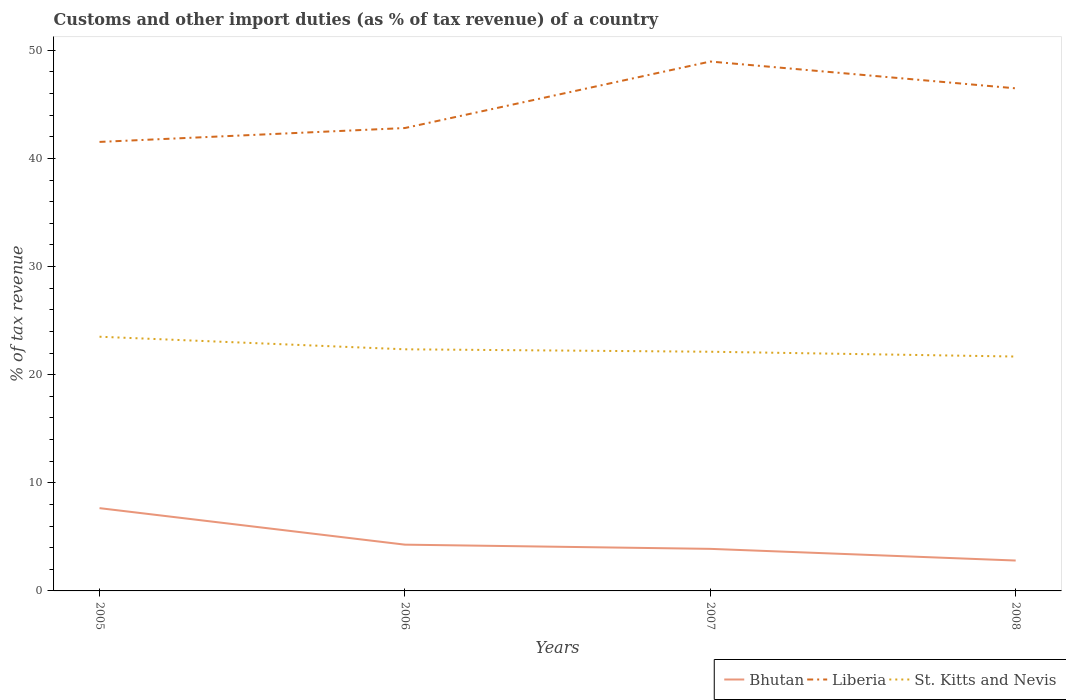Is the number of lines equal to the number of legend labels?
Keep it short and to the point. Yes. Across all years, what is the maximum percentage of tax revenue from customs in St. Kitts and Nevis?
Make the answer very short. 21.68. What is the total percentage of tax revenue from customs in Bhutan in the graph?
Give a very brief answer. 1.47. What is the difference between the highest and the second highest percentage of tax revenue from customs in St. Kitts and Nevis?
Ensure brevity in your answer.  1.83. What is the difference between the highest and the lowest percentage of tax revenue from customs in Liberia?
Your answer should be compact. 2. How many lines are there?
Your answer should be very brief. 3. How many years are there in the graph?
Ensure brevity in your answer.  4. What is the difference between two consecutive major ticks on the Y-axis?
Keep it short and to the point. 10. Are the values on the major ticks of Y-axis written in scientific E-notation?
Your answer should be very brief. No. How many legend labels are there?
Offer a terse response. 3. What is the title of the graph?
Offer a terse response. Customs and other import duties (as % of tax revenue) of a country. Does "Jamaica" appear as one of the legend labels in the graph?
Offer a very short reply. No. What is the label or title of the Y-axis?
Keep it short and to the point. % of tax revenue. What is the % of tax revenue in Bhutan in 2005?
Provide a succinct answer. 7.66. What is the % of tax revenue in Liberia in 2005?
Your answer should be compact. 41.53. What is the % of tax revenue of St. Kitts and Nevis in 2005?
Ensure brevity in your answer.  23.51. What is the % of tax revenue of Bhutan in 2006?
Offer a terse response. 4.28. What is the % of tax revenue in Liberia in 2006?
Give a very brief answer. 42.81. What is the % of tax revenue in St. Kitts and Nevis in 2006?
Provide a short and direct response. 22.35. What is the % of tax revenue in Bhutan in 2007?
Provide a succinct answer. 3.89. What is the % of tax revenue of Liberia in 2007?
Make the answer very short. 48.96. What is the % of tax revenue in St. Kitts and Nevis in 2007?
Your answer should be compact. 22.12. What is the % of tax revenue of Bhutan in 2008?
Give a very brief answer. 2.81. What is the % of tax revenue of Liberia in 2008?
Offer a terse response. 46.48. What is the % of tax revenue in St. Kitts and Nevis in 2008?
Provide a succinct answer. 21.68. Across all years, what is the maximum % of tax revenue in Bhutan?
Offer a terse response. 7.66. Across all years, what is the maximum % of tax revenue of Liberia?
Provide a short and direct response. 48.96. Across all years, what is the maximum % of tax revenue of St. Kitts and Nevis?
Offer a terse response. 23.51. Across all years, what is the minimum % of tax revenue in Bhutan?
Your response must be concise. 2.81. Across all years, what is the minimum % of tax revenue of Liberia?
Ensure brevity in your answer.  41.53. Across all years, what is the minimum % of tax revenue of St. Kitts and Nevis?
Your answer should be very brief. 21.68. What is the total % of tax revenue of Bhutan in the graph?
Ensure brevity in your answer.  18.64. What is the total % of tax revenue of Liberia in the graph?
Make the answer very short. 179.79. What is the total % of tax revenue in St. Kitts and Nevis in the graph?
Provide a succinct answer. 89.66. What is the difference between the % of tax revenue in Bhutan in 2005 and that in 2006?
Provide a short and direct response. 3.38. What is the difference between the % of tax revenue in Liberia in 2005 and that in 2006?
Your response must be concise. -1.28. What is the difference between the % of tax revenue of St. Kitts and Nevis in 2005 and that in 2006?
Make the answer very short. 1.16. What is the difference between the % of tax revenue in Bhutan in 2005 and that in 2007?
Ensure brevity in your answer.  3.77. What is the difference between the % of tax revenue in Liberia in 2005 and that in 2007?
Your answer should be compact. -7.44. What is the difference between the % of tax revenue in St. Kitts and Nevis in 2005 and that in 2007?
Keep it short and to the point. 1.39. What is the difference between the % of tax revenue in Bhutan in 2005 and that in 2008?
Your answer should be very brief. 4.85. What is the difference between the % of tax revenue of Liberia in 2005 and that in 2008?
Provide a short and direct response. -4.96. What is the difference between the % of tax revenue in St. Kitts and Nevis in 2005 and that in 2008?
Provide a succinct answer. 1.83. What is the difference between the % of tax revenue in Bhutan in 2006 and that in 2007?
Offer a terse response. 0.39. What is the difference between the % of tax revenue of Liberia in 2006 and that in 2007?
Make the answer very short. -6.15. What is the difference between the % of tax revenue of St. Kitts and Nevis in 2006 and that in 2007?
Your answer should be very brief. 0.22. What is the difference between the % of tax revenue in Bhutan in 2006 and that in 2008?
Offer a very short reply. 1.47. What is the difference between the % of tax revenue of Liberia in 2006 and that in 2008?
Ensure brevity in your answer.  -3.67. What is the difference between the % of tax revenue of St. Kitts and Nevis in 2006 and that in 2008?
Provide a succinct answer. 0.67. What is the difference between the % of tax revenue of Bhutan in 2007 and that in 2008?
Your response must be concise. 1.08. What is the difference between the % of tax revenue of Liberia in 2007 and that in 2008?
Keep it short and to the point. 2.48. What is the difference between the % of tax revenue of St. Kitts and Nevis in 2007 and that in 2008?
Your response must be concise. 0.44. What is the difference between the % of tax revenue of Bhutan in 2005 and the % of tax revenue of Liberia in 2006?
Provide a succinct answer. -35.16. What is the difference between the % of tax revenue in Bhutan in 2005 and the % of tax revenue in St. Kitts and Nevis in 2006?
Give a very brief answer. -14.69. What is the difference between the % of tax revenue of Liberia in 2005 and the % of tax revenue of St. Kitts and Nevis in 2006?
Offer a very short reply. 19.18. What is the difference between the % of tax revenue in Bhutan in 2005 and the % of tax revenue in Liberia in 2007?
Keep it short and to the point. -41.31. What is the difference between the % of tax revenue of Bhutan in 2005 and the % of tax revenue of St. Kitts and Nevis in 2007?
Offer a terse response. -14.47. What is the difference between the % of tax revenue of Liberia in 2005 and the % of tax revenue of St. Kitts and Nevis in 2007?
Offer a terse response. 19.41. What is the difference between the % of tax revenue in Bhutan in 2005 and the % of tax revenue in Liberia in 2008?
Make the answer very short. -38.83. What is the difference between the % of tax revenue in Bhutan in 2005 and the % of tax revenue in St. Kitts and Nevis in 2008?
Offer a very short reply. -14.02. What is the difference between the % of tax revenue in Liberia in 2005 and the % of tax revenue in St. Kitts and Nevis in 2008?
Keep it short and to the point. 19.85. What is the difference between the % of tax revenue in Bhutan in 2006 and the % of tax revenue in Liberia in 2007?
Offer a terse response. -44.68. What is the difference between the % of tax revenue in Bhutan in 2006 and the % of tax revenue in St. Kitts and Nevis in 2007?
Give a very brief answer. -17.84. What is the difference between the % of tax revenue of Liberia in 2006 and the % of tax revenue of St. Kitts and Nevis in 2007?
Make the answer very short. 20.69. What is the difference between the % of tax revenue of Bhutan in 2006 and the % of tax revenue of Liberia in 2008?
Your response must be concise. -42.21. What is the difference between the % of tax revenue of Bhutan in 2006 and the % of tax revenue of St. Kitts and Nevis in 2008?
Provide a succinct answer. -17.4. What is the difference between the % of tax revenue of Liberia in 2006 and the % of tax revenue of St. Kitts and Nevis in 2008?
Make the answer very short. 21.13. What is the difference between the % of tax revenue in Bhutan in 2007 and the % of tax revenue in Liberia in 2008?
Your answer should be compact. -42.59. What is the difference between the % of tax revenue of Bhutan in 2007 and the % of tax revenue of St. Kitts and Nevis in 2008?
Your answer should be very brief. -17.79. What is the difference between the % of tax revenue of Liberia in 2007 and the % of tax revenue of St. Kitts and Nevis in 2008?
Give a very brief answer. 27.29. What is the average % of tax revenue in Bhutan per year?
Give a very brief answer. 4.66. What is the average % of tax revenue in Liberia per year?
Ensure brevity in your answer.  44.95. What is the average % of tax revenue in St. Kitts and Nevis per year?
Make the answer very short. 22.41. In the year 2005, what is the difference between the % of tax revenue of Bhutan and % of tax revenue of Liberia?
Provide a succinct answer. -33.87. In the year 2005, what is the difference between the % of tax revenue in Bhutan and % of tax revenue in St. Kitts and Nevis?
Provide a succinct answer. -15.85. In the year 2005, what is the difference between the % of tax revenue of Liberia and % of tax revenue of St. Kitts and Nevis?
Give a very brief answer. 18.02. In the year 2006, what is the difference between the % of tax revenue in Bhutan and % of tax revenue in Liberia?
Your response must be concise. -38.53. In the year 2006, what is the difference between the % of tax revenue in Bhutan and % of tax revenue in St. Kitts and Nevis?
Provide a short and direct response. -18.07. In the year 2006, what is the difference between the % of tax revenue of Liberia and % of tax revenue of St. Kitts and Nevis?
Provide a short and direct response. 20.47. In the year 2007, what is the difference between the % of tax revenue in Bhutan and % of tax revenue in Liberia?
Your response must be concise. -45.07. In the year 2007, what is the difference between the % of tax revenue of Bhutan and % of tax revenue of St. Kitts and Nevis?
Your answer should be compact. -18.23. In the year 2007, what is the difference between the % of tax revenue of Liberia and % of tax revenue of St. Kitts and Nevis?
Offer a very short reply. 26.84. In the year 2008, what is the difference between the % of tax revenue of Bhutan and % of tax revenue of Liberia?
Provide a short and direct response. -43.67. In the year 2008, what is the difference between the % of tax revenue of Bhutan and % of tax revenue of St. Kitts and Nevis?
Keep it short and to the point. -18.87. In the year 2008, what is the difference between the % of tax revenue in Liberia and % of tax revenue in St. Kitts and Nevis?
Keep it short and to the point. 24.81. What is the ratio of the % of tax revenue of Bhutan in 2005 to that in 2006?
Make the answer very short. 1.79. What is the ratio of the % of tax revenue in Liberia in 2005 to that in 2006?
Your answer should be very brief. 0.97. What is the ratio of the % of tax revenue of St. Kitts and Nevis in 2005 to that in 2006?
Your answer should be very brief. 1.05. What is the ratio of the % of tax revenue of Bhutan in 2005 to that in 2007?
Your answer should be compact. 1.97. What is the ratio of the % of tax revenue of Liberia in 2005 to that in 2007?
Offer a terse response. 0.85. What is the ratio of the % of tax revenue in St. Kitts and Nevis in 2005 to that in 2007?
Offer a very short reply. 1.06. What is the ratio of the % of tax revenue of Bhutan in 2005 to that in 2008?
Your answer should be compact. 2.72. What is the ratio of the % of tax revenue of Liberia in 2005 to that in 2008?
Offer a terse response. 0.89. What is the ratio of the % of tax revenue of St. Kitts and Nevis in 2005 to that in 2008?
Your answer should be compact. 1.08. What is the ratio of the % of tax revenue in Bhutan in 2006 to that in 2007?
Keep it short and to the point. 1.1. What is the ratio of the % of tax revenue of Liberia in 2006 to that in 2007?
Your answer should be very brief. 0.87. What is the ratio of the % of tax revenue in St. Kitts and Nevis in 2006 to that in 2007?
Keep it short and to the point. 1.01. What is the ratio of the % of tax revenue in Bhutan in 2006 to that in 2008?
Provide a short and direct response. 1.52. What is the ratio of the % of tax revenue of Liberia in 2006 to that in 2008?
Your answer should be very brief. 0.92. What is the ratio of the % of tax revenue of St. Kitts and Nevis in 2006 to that in 2008?
Keep it short and to the point. 1.03. What is the ratio of the % of tax revenue in Bhutan in 2007 to that in 2008?
Provide a short and direct response. 1.38. What is the ratio of the % of tax revenue in Liberia in 2007 to that in 2008?
Offer a terse response. 1.05. What is the ratio of the % of tax revenue of St. Kitts and Nevis in 2007 to that in 2008?
Your answer should be very brief. 1.02. What is the difference between the highest and the second highest % of tax revenue in Bhutan?
Keep it short and to the point. 3.38. What is the difference between the highest and the second highest % of tax revenue of Liberia?
Keep it short and to the point. 2.48. What is the difference between the highest and the second highest % of tax revenue of St. Kitts and Nevis?
Your response must be concise. 1.16. What is the difference between the highest and the lowest % of tax revenue in Bhutan?
Provide a succinct answer. 4.85. What is the difference between the highest and the lowest % of tax revenue of Liberia?
Your answer should be compact. 7.44. What is the difference between the highest and the lowest % of tax revenue in St. Kitts and Nevis?
Make the answer very short. 1.83. 